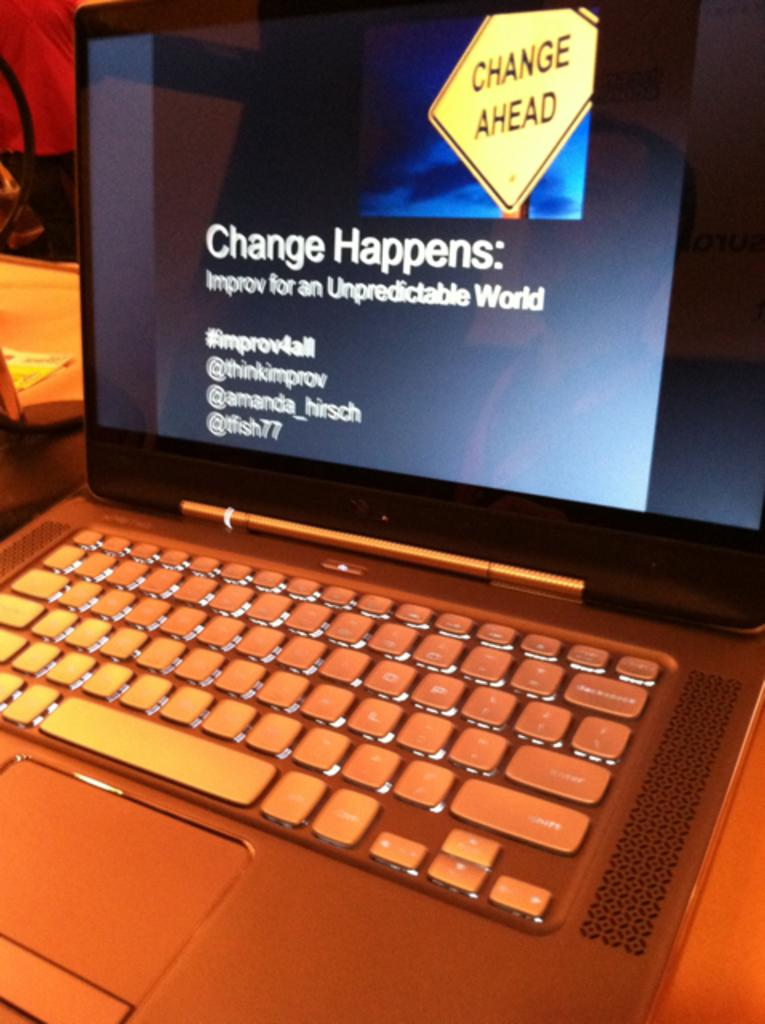<image>
Write a terse but informative summary of the picture. The laptop screen suggests that there will be change ahead. 